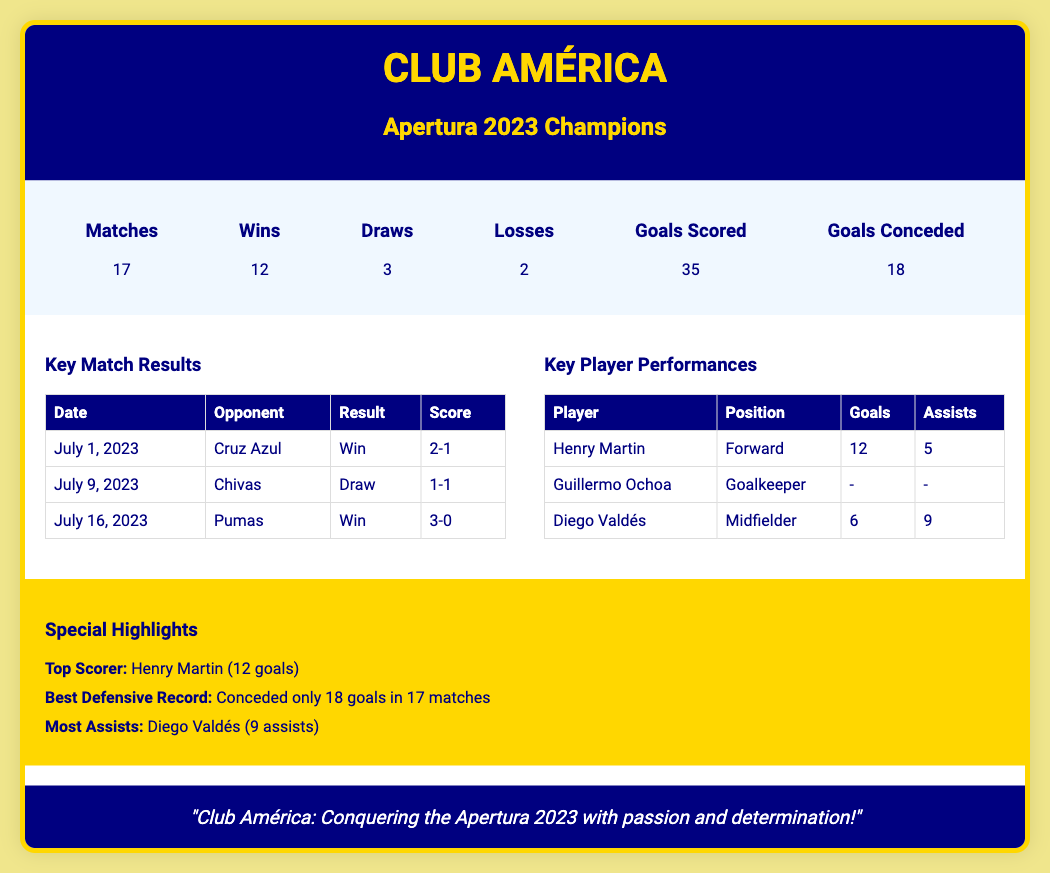What is the team featured in this document? The header indicates that the featured team is Club América.
Answer: Club América How many matches did Club América play in the season? In the season summary section, it specifies that the total number of matches played is 17.
Answer: 17 What was Club América's total goals scored throughout the season? The season summary states that Club América scored a total of 35 goals.
Answer: 35 Who was the top scorer for Club América? The highlights section identifies Henry Martin as the top scorer with 12 goals.
Answer: Henry Martin What was the final score against Pumas on July 16, 2023? The match results section lists the outcome of the match against Pumas showing a score of 3-0.
Answer: 3-0 How many assists did Diego Valdés provide? In the key player performances table, it shows that Diego Valdés had 9 assists.
Answer: 9 What was the best defensive record for Club América? The highlights section mentions that they conceded only 18 goals in 17 matches, indicating their solid defense.
Answer: Conceded only 18 goals What motivates Club América according to the team quote? The quote in the document highlights the team's passion and determination as their motivation in the league.
Answer: Passion and determination How many wins did Club América achieve in the season? The season summary indicates that Club América achieved 12 wins throughout the season.
Answer: 12 